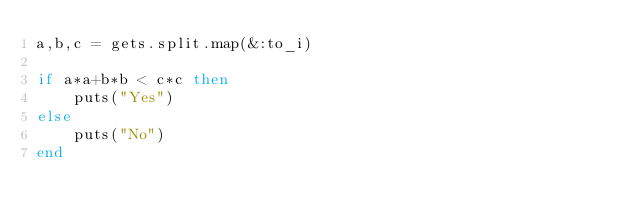Convert code to text. <code><loc_0><loc_0><loc_500><loc_500><_Ruby_>a,b,c = gets.split.map(&:to_i)

if a*a+b*b < c*c then
    puts("Yes") 
else
    puts("No")
end</code> 